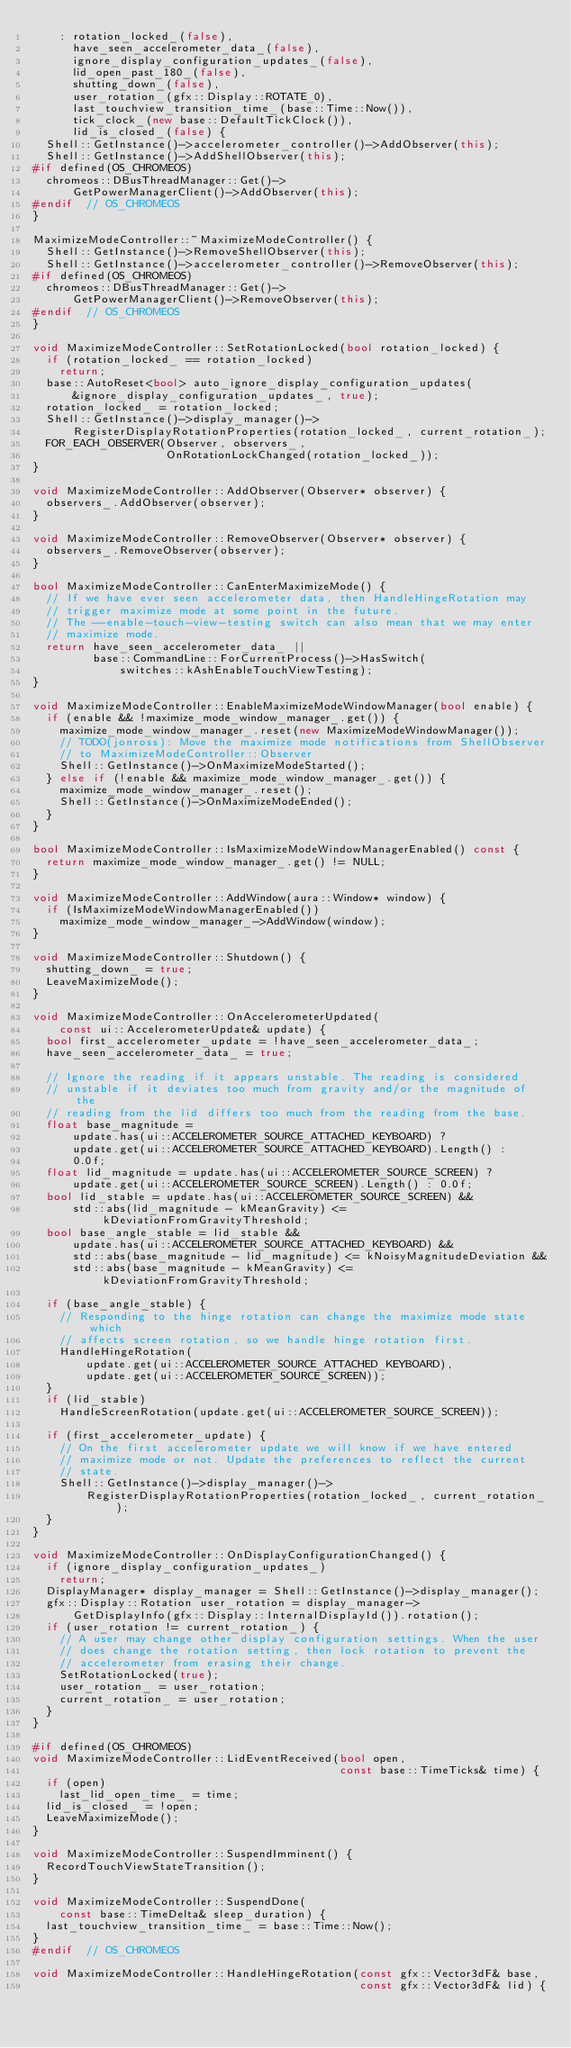Convert code to text. <code><loc_0><loc_0><loc_500><loc_500><_C++_>    : rotation_locked_(false),
      have_seen_accelerometer_data_(false),
      ignore_display_configuration_updates_(false),
      lid_open_past_180_(false),
      shutting_down_(false),
      user_rotation_(gfx::Display::ROTATE_0),
      last_touchview_transition_time_(base::Time::Now()),
      tick_clock_(new base::DefaultTickClock()),
      lid_is_closed_(false) {
  Shell::GetInstance()->accelerometer_controller()->AddObserver(this);
  Shell::GetInstance()->AddShellObserver(this);
#if defined(OS_CHROMEOS)
  chromeos::DBusThreadManager::Get()->
      GetPowerManagerClient()->AddObserver(this);
#endif  // OS_CHROMEOS
}

MaximizeModeController::~MaximizeModeController() {
  Shell::GetInstance()->RemoveShellObserver(this);
  Shell::GetInstance()->accelerometer_controller()->RemoveObserver(this);
#if defined(OS_CHROMEOS)
  chromeos::DBusThreadManager::Get()->
      GetPowerManagerClient()->RemoveObserver(this);
#endif  // OS_CHROMEOS
}

void MaximizeModeController::SetRotationLocked(bool rotation_locked) {
  if (rotation_locked_ == rotation_locked)
    return;
  base::AutoReset<bool> auto_ignore_display_configuration_updates(
      &ignore_display_configuration_updates_, true);
  rotation_locked_ = rotation_locked;
  Shell::GetInstance()->display_manager()->
      RegisterDisplayRotationProperties(rotation_locked_, current_rotation_);
  FOR_EACH_OBSERVER(Observer, observers_,
                    OnRotationLockChanged(rotation_locked_));
}

void MaximizeModeController::AddObserver(Observer* observer) {
  observers_.AddObserver(observer);
}

void MaximizeModeController::RemoveObserver(Observer* observer) {
  observers_.RemoveObserver(observer);
}

bool MaximizeModeController::CanEnterMaximizeMode() {
  // If we have ever seen accelerometer data, then HandleHingeRotation may
  // trigger maximize mode at some point in the future.
  // The --enable-touch-view-testing switch can also mean that we may enter
  // maximize mode.
  return have_seen_accelerometer_data_ ||
         base::CommandLine::ForCurrentProcess()->HasSwitch(
             switches::kAshEnableTouchViewTesting);
}

void MaximizeModeController::EnableMaximizeModeWindowManager(bool enable) {
  if (enable && !maximize_mode_window_manager_.get()) {
    maximize_mode_window_manager_.reset(new MaximizeModeWindowManager());
    // TODO(jonross): Move the maximize mode notifications from ShellObserver
    // to MaximizeModeController::Observer
    Shell::GetInstance()->OnMaximizeModeStarted();
  } else if (!enable && maximize_mode_window_manager_.get()) {
    maximize_mode_window_manager_.reset();
    Shell::GetInstance()->OnMaximizeModeEnded();
  }
}

bool MaximizeModeController::IsMaximizeModeWindowManagerEnabled() const {
  return maximize_mode_window_manager_.get() != NULL;
}

void MaximizeModeController::AddWindow(aura::Window* window) {
  if (IsMaximizeModeWindowManagerEnabled())
    maximize_mode_window_manager_->AddWindow(window);
}

void MaximizeModeController::Shutdown() {
  shutting_down_ = true;
  LeaveMaximizeMode();
}

void MaximizeModeController::OnAccelerometerUpdated(
    const ui::AccelerometerUpdate& update) {
  bool first_accelerometer_update = !have_seen_accelerometer_data_;
  have_seen_accelerometer_data_ = true;

  // Ignore the reading if it appears unstable. The reading is considered
  // unstable if it deviates too much from gravity and/or the magnitude of the
  // reading from the lid differs too much from the reading from the base.
  float base_magnitude =
      update.has(ui::ACCELEROMETER_SOURCE_ATTACHED_KEYBOARD) ?
      update.get(ui::ACCELEROMETER_SOURCE_ATTACHED_KEYBOARD).Length() :
      0.0f;
  float lid_magnitude = update.has(ui::ACCELEROMETER_SOURCE_SCREEN) ?
      update.get(ui::ACCELEROMETER_SOURCE_SCREEN).Length() : 0.0f;
  bool lid_stable = update.has(ui::ACCELEROMETER_SOURCE_SCREEN) &&
      std::abs(lid_magnitude - kMeanGravity) <= kDeviationFromGravityThreshold;
  bool base_angle_stable = lid_stable &&
      update.has(ui::ACCELEROMETER_SOURCE_ATTACHED_KEYBOARD) &&
      std::abs(base_magnitude - lid_magnitude) <= kNoisyMagnitudeDeviation &&
      std::abs(base_magnitude - kMeanGravity) <= kDeviationFromGravityThreshold;

  if (base_angle_stable) {
    // Responding to the hinge rotation can change the maximize mode state which
    // affects screen rotation, so we handle hinge rotation first.
    HandleHingeRotation(
        update.get(ui::ACCELEROMETER_SOURCE_ATTACHED_KEYBOARD),
        update.get(ui::ACCELEROMETER_SOURCE_SCREEN));
  }
  if (lid_stable)
    HandleScreenRotation(update.get(ui::ACCELEROMETER_SOURCE_SCREEN));

  if (first_accelerometer_update) {
    // On the first accelerometer update we will know if we have entered
    // maximize mode or not. Update the preferences to reflect the current
    // state.
    Shell::GetInstance()->display_manager()->
        RegisterDisplayRotationProperties(rotation_locked_, current_rotation_);
  }
}

void MaximizeModeController::OnDisplayConfigurationChanged() {
  if (ignore_display_configuration_updates_)
    return;
  DisplayManager* display_manager = Shell::GetInstance()->display_manager();
  gfx::Display::Rotation user_rotation = display_manager->
      GetDisplayInfo(gfx::Display::InternalDisplayId()).rotation();
  if (user_rotation != current_rotation_) {
    // A user may change other display configuration settings. When the user
    // does change the rotation setting, then lock rotation to prevent the
    // accelerometer from erasing their change.
    SetRotationLocked(true);
    user_rotation_ = user_rotation;
    current_rotation_ = user_rotation;
  }
}

#if defined(OS_CHROMEOS)
void MaximizeModeController::LidEventReceived(bool open,
                                              const base::TimeTicks& time) {
  if (open)
    last_lid_open_time_ = time;
  lid_is_closed_ = !open;
  LeaveMaximizeMode();
}

void MaximizeModeController::SuspendImminent() {
  RecordTouchViewStateTransition();
}

void MaximizeModeController::SuspendDone(
    const base::TimeDelta& sleep_duration) {
  last_touchview_transition_time_ = base::Time::Now();
}
#endif  // OS_CHROMEOS

void MaximizeModeController::HandleHingeRotation(const gfx::Vector3dF& base,
                                                 const gfx::Vector3dF& lid) {</code> 